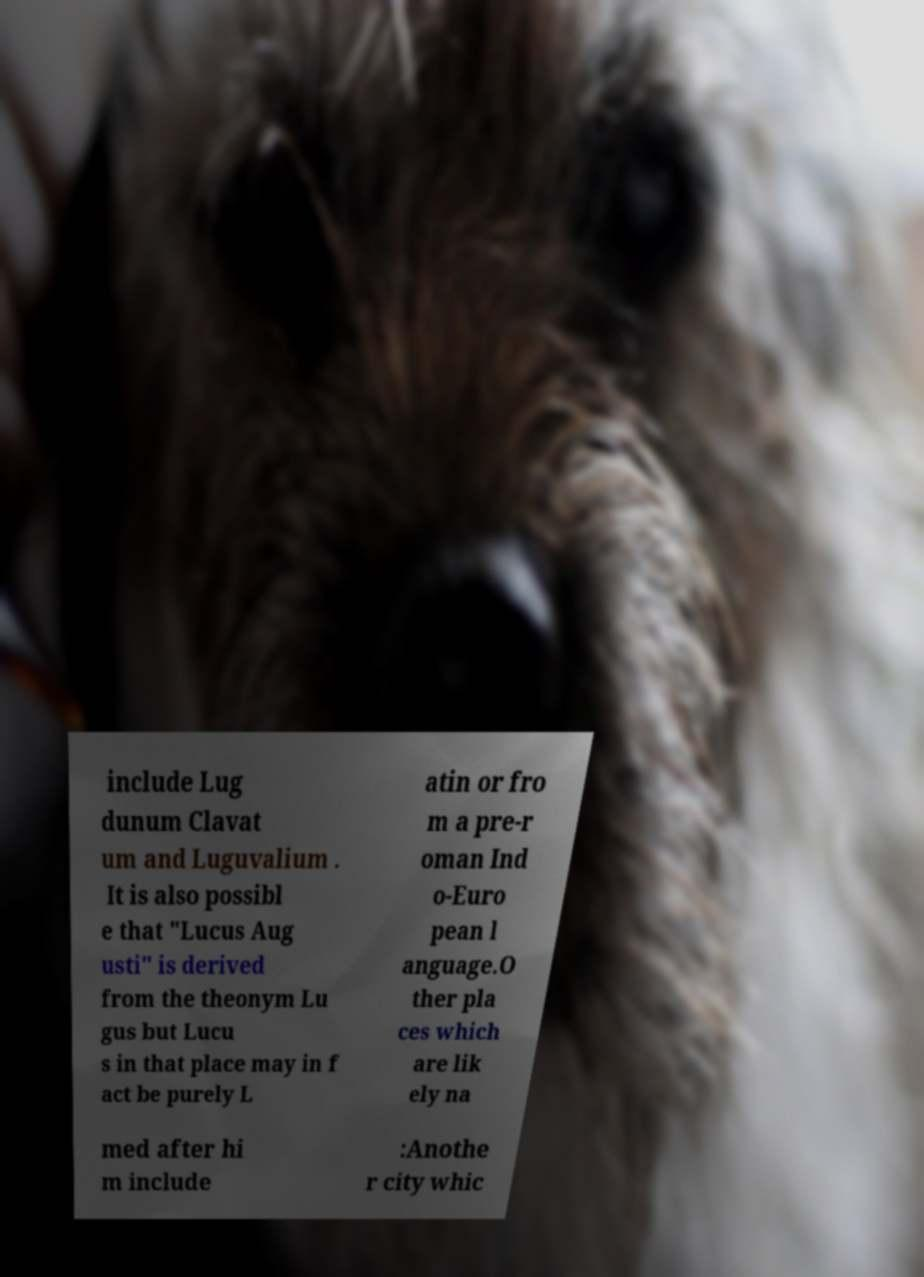I need the written content from this picture converted into text. Can you do that? include Lug dunum Clavat um and Luguvalium . It is also possibl e that "Lucus Aug usti" is derived from the theonym Lu gus but Lucu s in that place may in f act be purely L atin or fro m a pre-r oman Ind o-Euro pean l anguage.O ther pla ces which are lik ely na med after hi m include :Anothe r city whic 